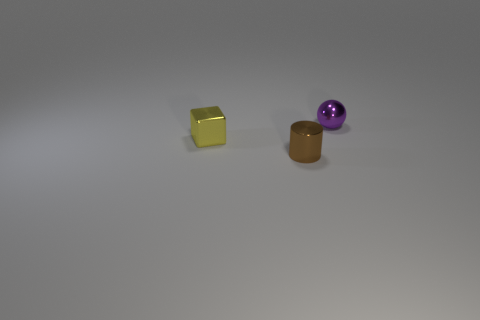Add 2 red balls. How many objects exist? 5 Subtract all cylinders. How many objects are left? 2 Add 1 small yellow metallic spheres. How many small yellow metallic spheres exist? 1 Subtract 0 blue cylinders. How many objects are left? 3 Subtract all red matte cylinders. Subtract all cylinders. How many objects are left? 2 Add 2 yellow metallic things. How many yellow metallic things are left? 3 